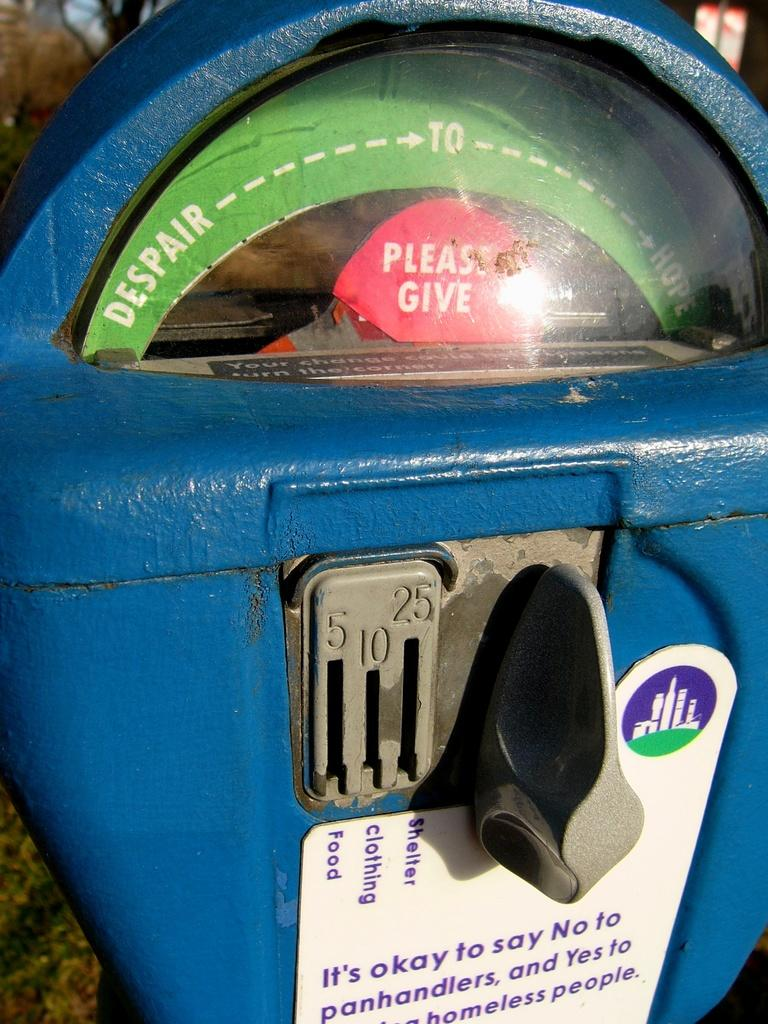<image>
Create a compact narrative representing the image presented. A parking meter that shows despair to hope and says Please Give. 